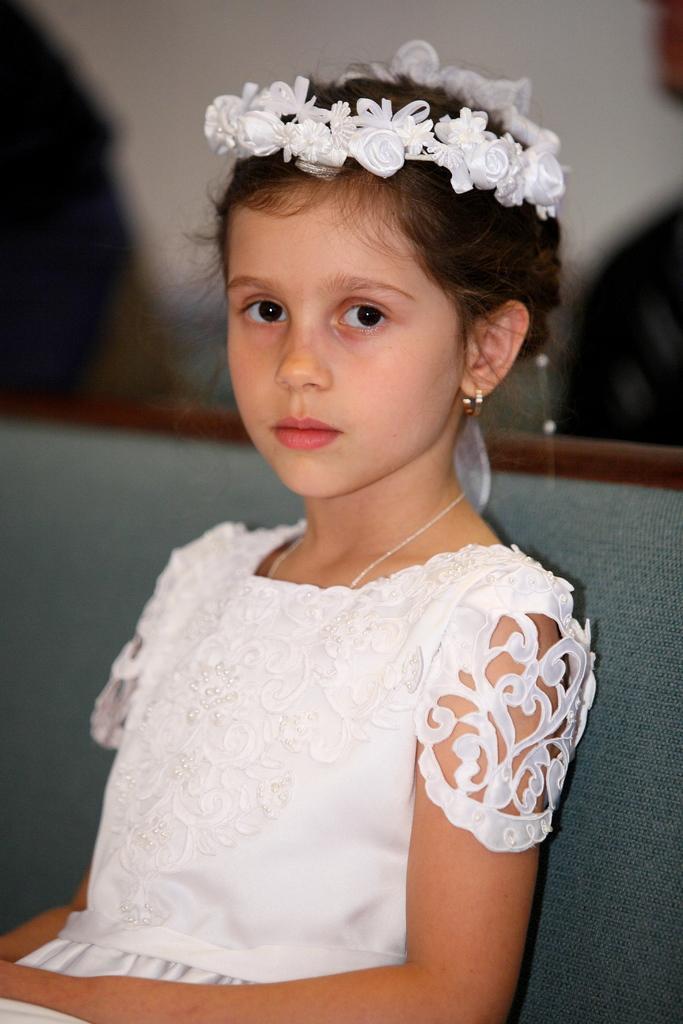Describe this image in one or two sentences. In this picture we can see a girl sitting on a chair and in the background it is blurry. 